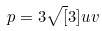Convert formula to latex. <formula><loc_0><loc_0><loc_500><loc_500>p = 3 \sqrt { [ } 3 ] { u v }</formula> 